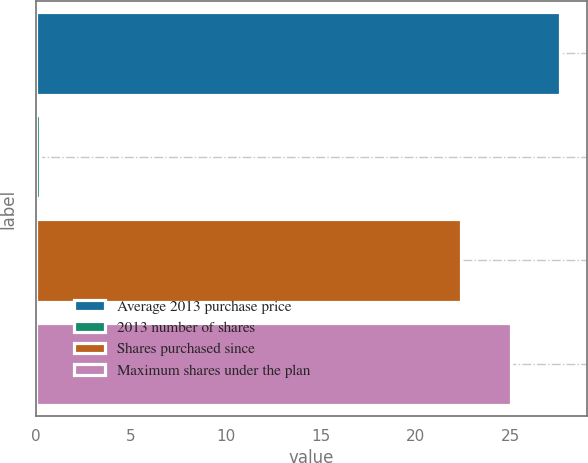Convert chart. <chart><loc_0><loc_0><loc_500><loc_500><bar_chart><fcel>Average 2013 purchase price<fcel>2013 number of shares<fcel>Shares purchased since<fcel>Maximum shares under the plan<nl><fcel>27.62<fcel>0.2<fcel>22.4<fcel>25.01<nl></chart> 